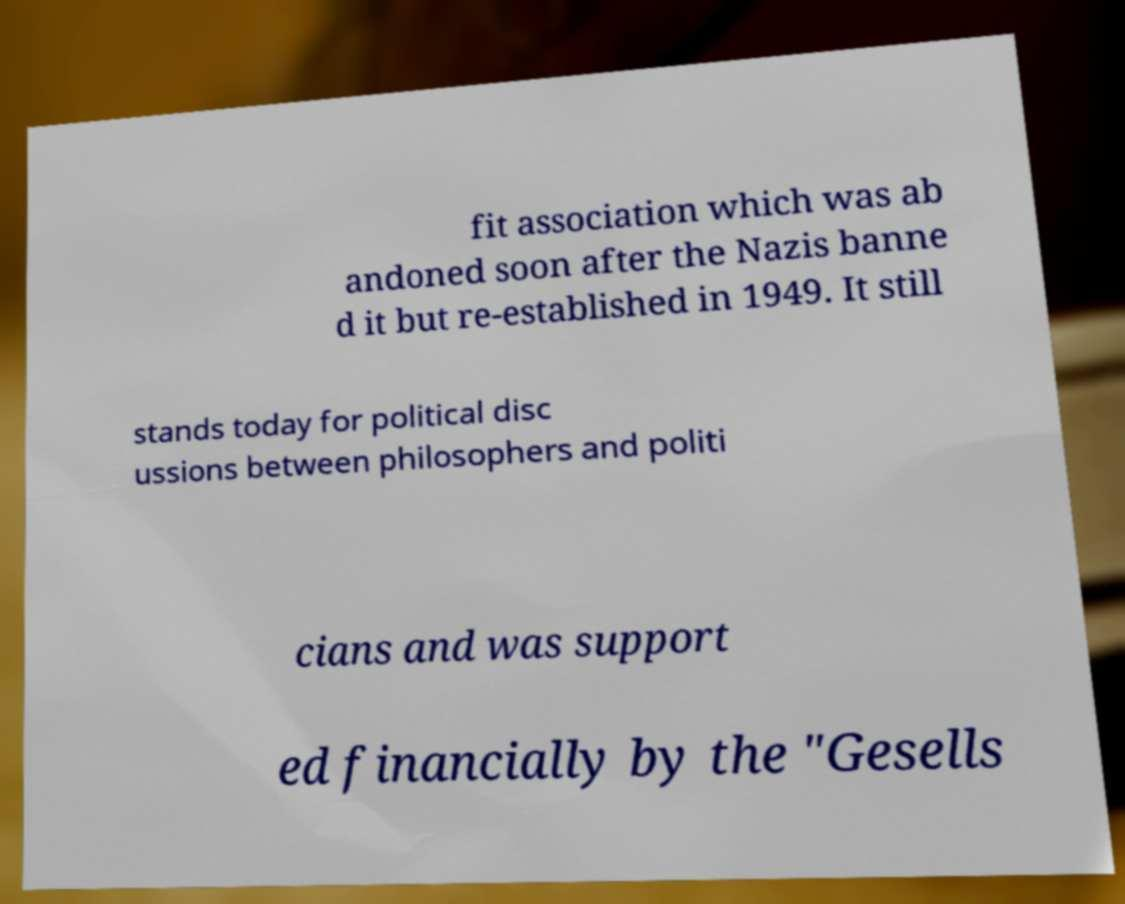Please read and relay the text visible in this image. What does it say? fit association which was ab andoned soon after the Nazis banne d it but re-established in 1949. It still stands today for political disc ussions between philosophers and politi cians and was support ed financially by the "Gesells 